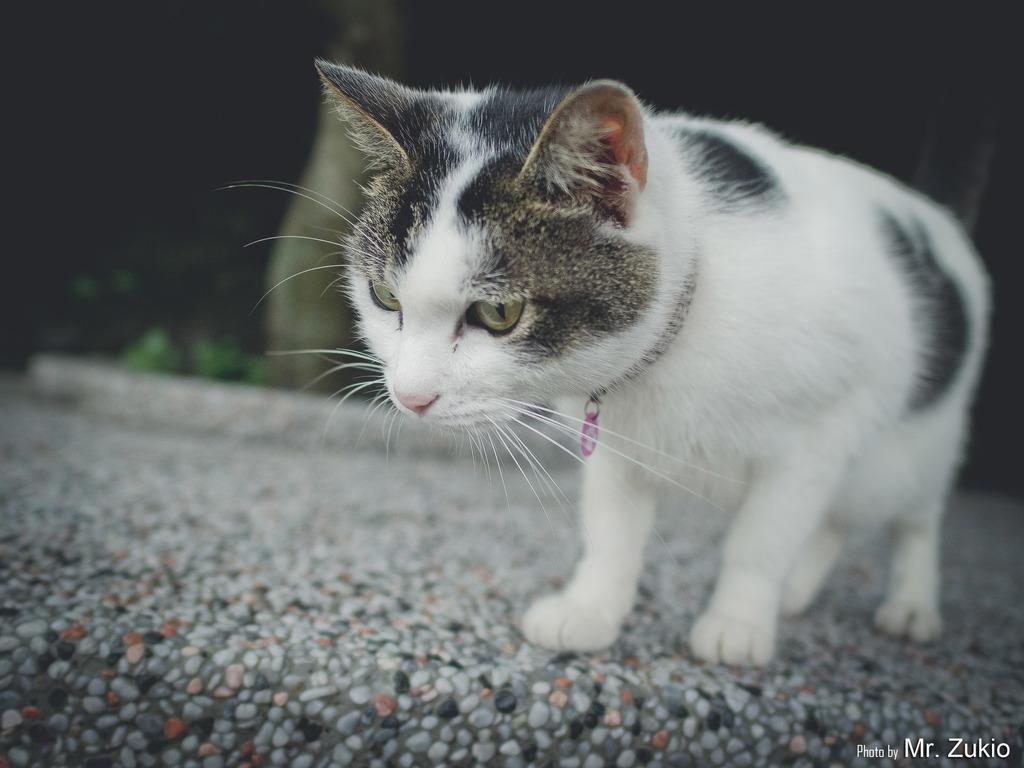What type of animal is present in the image? There is a cat in the image. Can you describe the color pattern of the cat? The cat is black and white in color. What type of toy is the maid using to play with the cat in the image? There is no maid or toy present in the image; it only features a cat. 